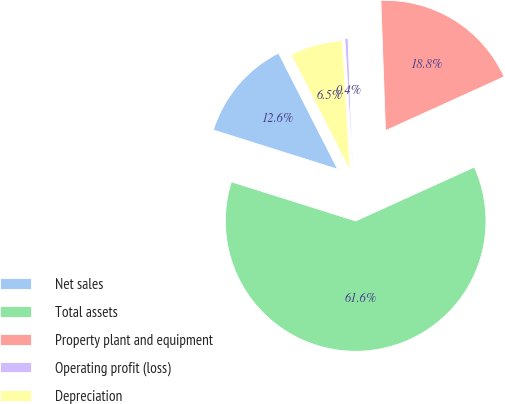Convert chart to OTSL. <chart><loc_0><loc_0><loc_500><loc_500><pie_chart><fcel>Net sales<fcel>Total assets<fcel>Property plant and equipment<fcel>Operating profit (loss)<fcel>Depreciation<nl><fcel>12.65%<fcel>61.64%<fcel>18.78%<fcel>0.4%<fcel>6.53%<nl></chart> 